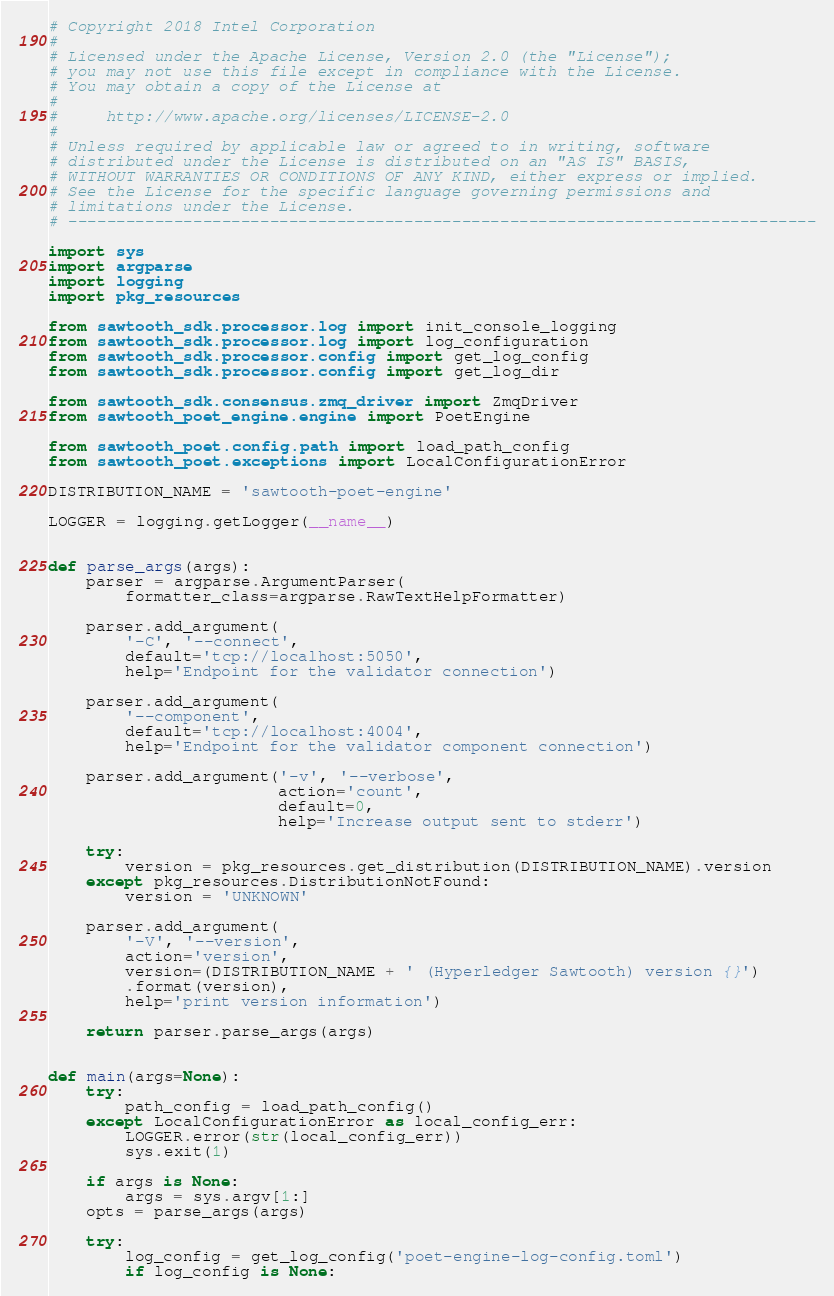Convert code to text. <code><loc_0><loc_0><loc_500><loc_500><_Python_># Copyright 2018 Intel Corporation
#
# Licensed under the Apache License, Version 2.0 (the "License");
# you may not use this file except in compliance with the License.
# You may obtain a copy of the License at
#
#     http://www.apache.org/licenses/LICENSE-2.0
#
# Unless required by applicable law or agreed to in writing, software
# distributed under the License is distributed on an "AS IS" BASIS,
# WITHOUT WARRANTIES OR CONDITIONS OF ANY KIND, either express or implied.
# See the License for the specific language governing permissions and
# limitations under the License.
# ------------------------------------------------------------------------------

import sys
import argparse
import logging
import pkg_resources

from sawtooth_sdk.processor.log import init_console_logging
from sawtooth_sdk.processor.log import log_configuration
from sawtooth_sdk.processor.config import get_log_config
from sawtooth_sdk.processor.config import get_log_dir

from sawtooth_sdk.consensus.zmq_driver import ZmqDriver
from sawtooth_poet_engine.engine import PoetEngine

from sawtooth_poet.config.path import load_path_config
from sawtooth_poet.exceptions import LocalConfigurationError

DISTRIBUTION_NAME = 'sawtooth-poet-engine'

LOGGER = logging.getLogger(__name__)


def parse_args(args):
    parser = argparse.ArgumentParser(
        formatter_class=argparse.RawTextHelpFormatter)

    parser.add_argument(
        '-C', '--connect',
        default='tcp://localhost:5050',
        help='Endpoint for the validator connection')

    parser.add_argument(
        '--component',
        default='tcp://localhost:4004',
        help='Endpoint for the validator component connection')

    parser.add_argument('-v', '--verbose',
                        action='count',
                        default=0,
                        help='Increase output sent to stderr')

    try:
        version = pkg_resources.get_distribution(DISTRIBUTION_NAME).version
    except pkg_resources.DistributionNotFound:
        version = 'UNKNOWN'

    parser.add_argument(
        '-V', '--version',
        action='version',
        version=(DISTRIBUTION_NAME + ' (Hyperledger Sawtooth) version {}')
        .format(version),
        help='print version information')

    return parser.parse_args(args)


def main(args=None):
    try:
        path_config = load_path_config()
    except LocalConfigurationError as local_config_err:
        LOGGER.error(str(local_config_err))
        sys.exit(1)

    if args is None:
        args = sys.argv[1:]
    opts = parse_args(args)

    try:
        log_config = get_log_config('poet-engine-log-config.toml')
        if log_config is None:</code> 